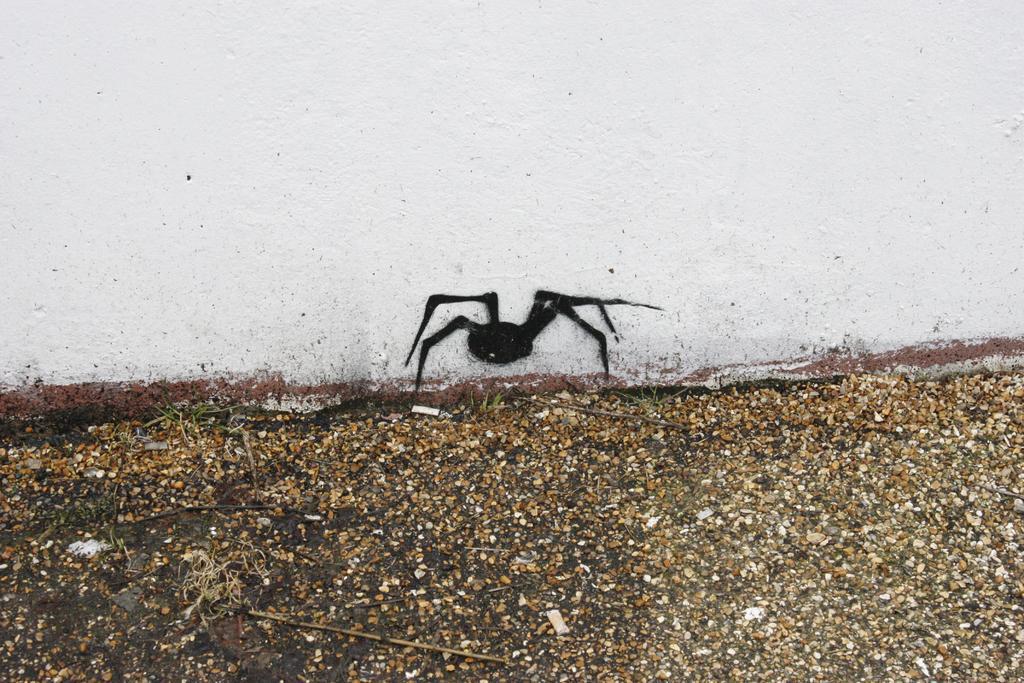Can you describe this image briefly? In this image I can see the ground and the white colored wall. On the wall I can see the black colored painting of an insect. 